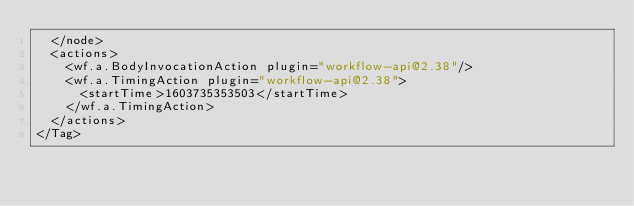<code> <loc_0><loc_0><loc_500><loc_500><_XML_>  </node>
  <actions>
    <wf.a.BodyInvocationAction plugin="workflow-api@2.38"/>
    <wf.a.TimingAction plugin="workflow-api@2.38">
      <startTime>1603735353503</startTime>
    </wf.a.TimingAction>
  </actions>
</Tag></code> 